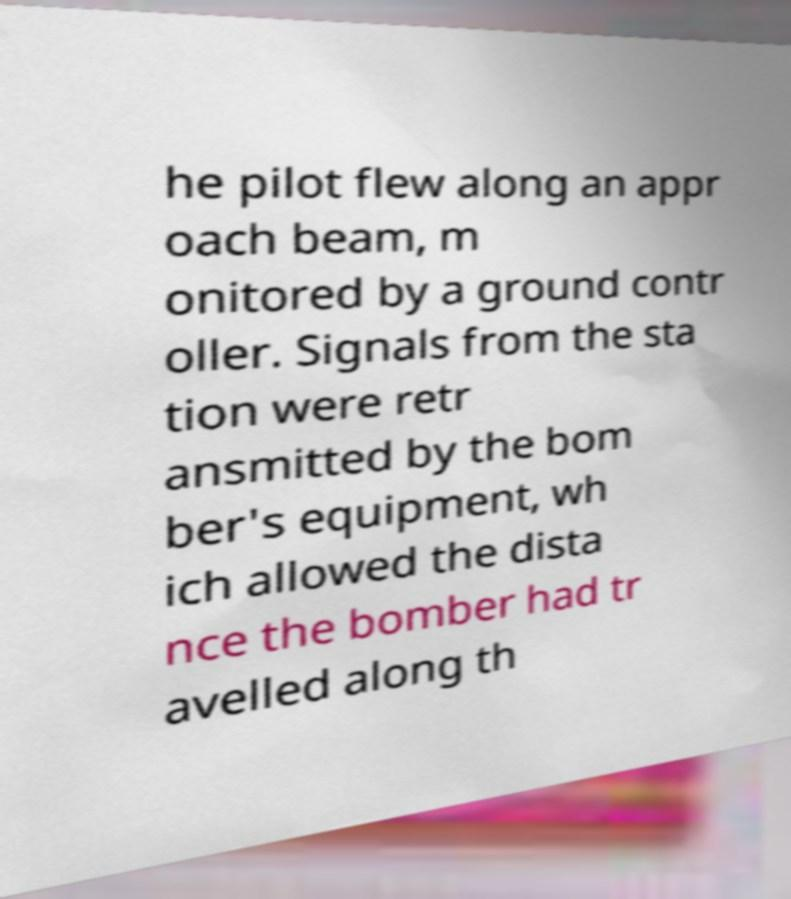Could you extract and type out the text from this image? he pilot flew along an appr oach beam, m onitored by a ground contr oller. Signals from the sta tion were retr ansmitted by the bom ber's equipment, wh ich allowed the dista nce the bomber had tr avelled along th 